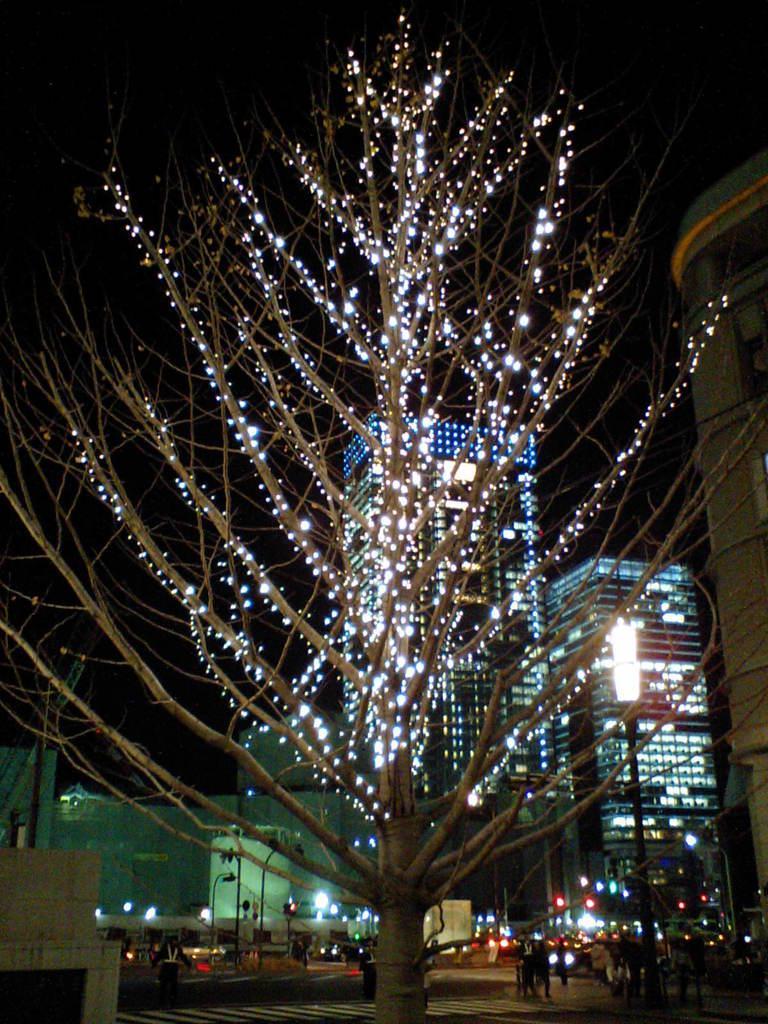In one or two sentences, can you explain what this image depicts? In this image I see a tree over here on which there are lights and I see the road and I see number of people and vehicles. In the background I see the buildings and I see the light poles and I see that it is dark in the background. 